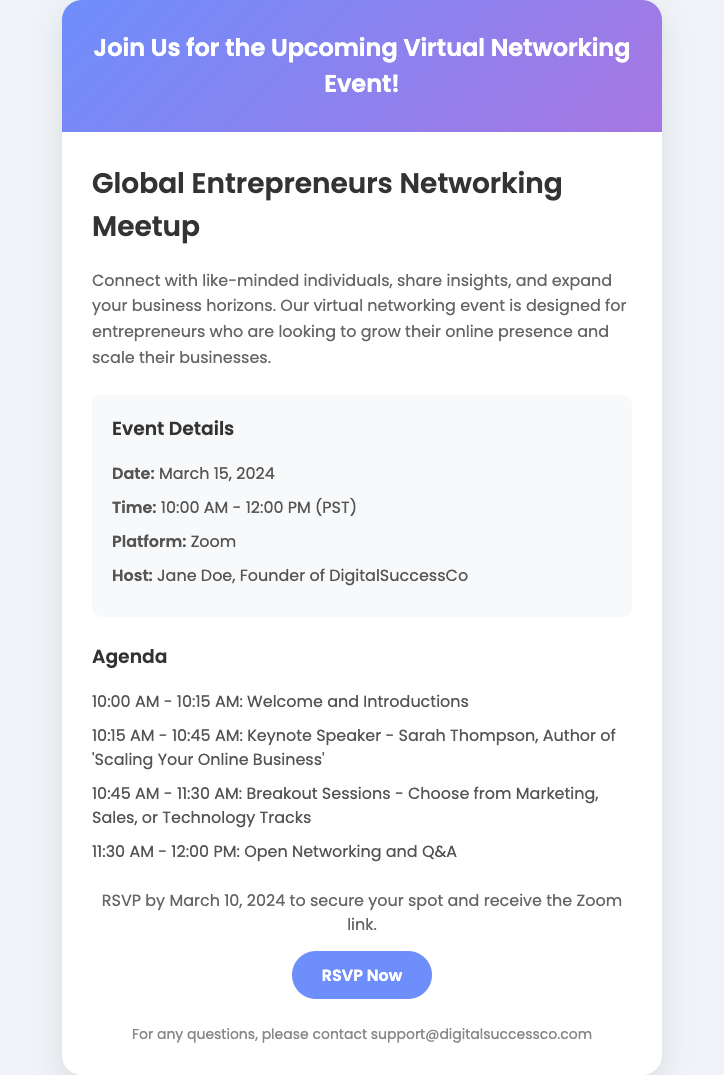what is the date of the event? The date of the event is specified in the event details section, which states the event will take place on March 15, 2024.
Answer: March 15, 2024 what time does the event start? The starting time of the event is mentioned as 10:00 AM in the event details section.
Answer: 10:00 AM who is the host of the event? The host's name, Jane Doe, is given in the event details section under "Host."
Answer: Jane Doe what will be the duration of the event? The event is scheduled from 10:00 AM to 12:00 PM, resulting in a total duration of 2 hours.
Answer: 2 hours what is the platform for the event? The platform for the event is indicated in the event details section as Zoom.
Answer: Zoom what is the deadline to RSVP? The RSVP deadline is stated in the call-to-action section as March 10, 2024.
Answer: March 10, 2024 how many tracks are available during breakout sessions? The agenda section indicates there are three choices for breakout sessions, hence there are three tracks available.
Answer: three who is the keynote speaker? The keynote speaker's name, Sarah Thompson, is mentioned in the agenda section.
Answer: Sarah Thompson what is the title of the keynote speech? The agenda specifies the title of the keynote speech as 'Scaling Your Online Business.'
Answer: Scaling Your Online Business 